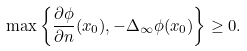Convert formula to latex. <formula><loc_0><loc_0><loc_500><loc_500>\max \left \{ \frac { \partial \phi } { \partial { n } } ( x _ { 0 } ) , - \Delta _ { \infty } \phi ( x _ { 0 } ) \right \} \geq 0 .</formula> 